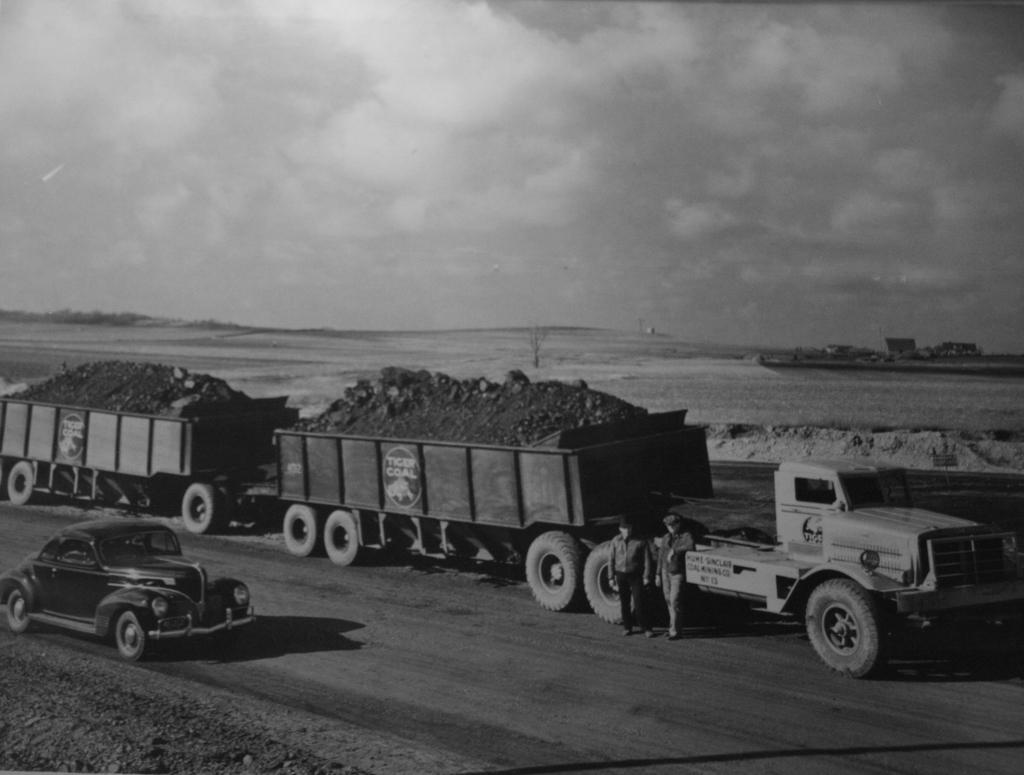What is the color scheme of the image? The image is black and white. What can be seen on the road in the image? There are vehicles and people on the road. What type of surface is visible in the image? There is land visible in the image. How many brothers are depicted in the image? There is no reference to any brothers in the image, so it is not possible to answer that question. 